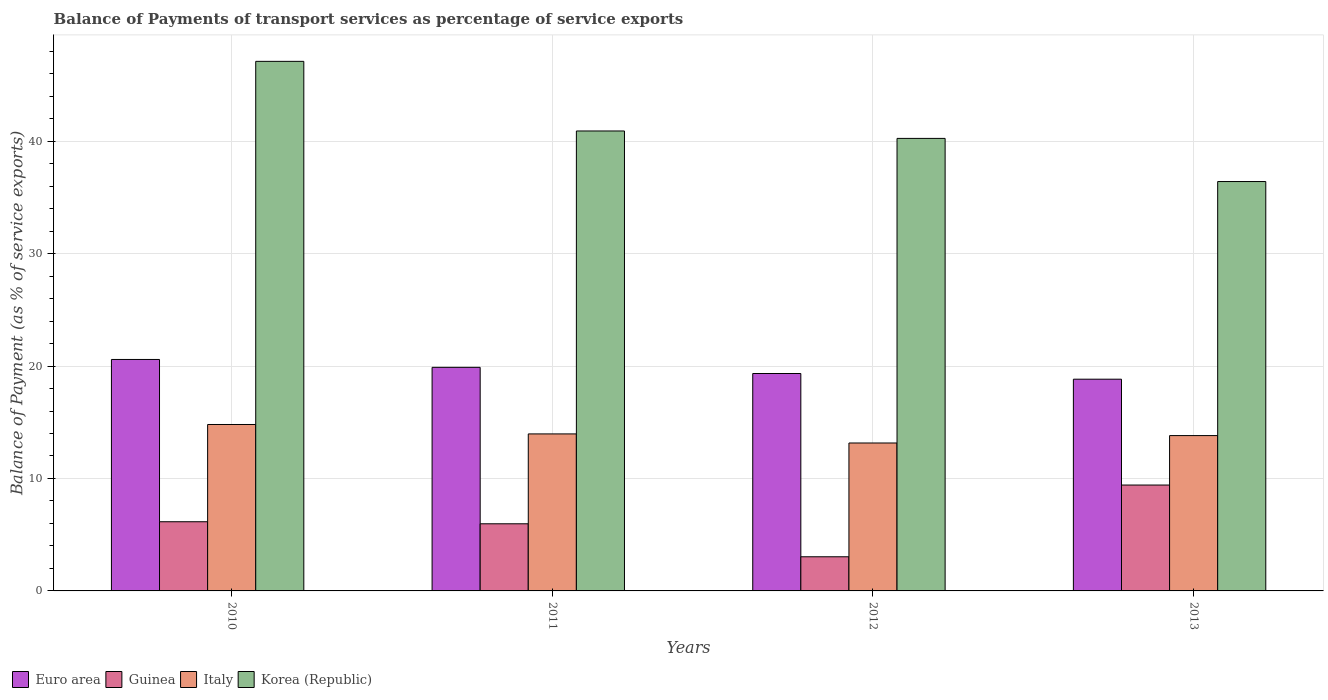How many groups of bars are there?
Give a very brief answer. 4. How many bars are there on the 1st tick from the left?
Your response must be concise. 4. What is the label of the 1st group of bars from the left?
Your response must be concise. 2010. What is the balance of payments of transport services in Guinea in 2010?
Ensure brevity in your answer.  6.15. Across all years, what is the maximum balance of payments of transport services in Guinea?
Provide a short and direct response. 9.42. Across all years, what is the minimum balance of payments of transport services in Italy?
Offer a very short reply. 13.16. In which year was the balance of payments of transport services in Guinea maximum?
Your answer should be very brief. 2013. What is the total balance of payments of transport services in Guinea in the graph?
Your answer should be very brief. 24.58. What is the difference between the balance of payments of transport services in Euro area in 2010 and that in 2012?
Provide a short and direct response. 1.25. What is the difference between the balance of payments of transport services in Italy in 2012 and the balance of payments of transport services in Euro area in 2013?
Your answer should be very brief. -5.67. What is the average balance of payments of transport services in Euro area per year?
Give a very brief answer. 19.66. In the year 2011, what is the difference between the balance of payments of transport services in Guinea and balance of payments of transport services in Italy?
Offer a terse response. -7.99. What is the ratio of the balance of payments of transport services in Euro area in 2011 to that in 2012?
Provide a short and direct response. 1.03. Is the balance of payments of transport services in Euro area in 2010 less than that in 2012?
Offer a terse response. No. Is the difference between the balance of payments of transport services in Guinea in 2012 and 2013 greater than the difference between the balance of payments of transport services in Italy in 2012 and 2013?
Offer a terse response. No. What is the difference between the highest and the second highest balance of payments of transport services in Euro area?
Provide a short and direct response. 0.7. What is the difference between the highest and the lowest balance of payments of transport services in Guinea?
Provide a succinct answer. 6.38. In how many years, is the balance of payments of transport services in Guinea greater than the average balance of payments of transport services in Guinea taken over all years?
Your response must be concise. 2. Is it the case that in every year, the sum of the balance of payments of transport services in Korea (Republic) and balance of payments of transport services in Guinea is greater than the sum of balance of payments of transport services in Euro area and balance of payments of transport services in Italy?
Provide a short and direct response. Yes. Are all the bars in the graph horizontal?
Your response must be concise. No. What is the difference between two consecutive major ticks on the Y-axis?
Your answer should be compact. 10. Are the values on the major ticks of Y-axis written in scientific E-notation?
Your response must be concise. No. Where does the legend appear in the graph?
Ensure brevity in your answer.  Bottom left. How many legend labels are there?
Ensure brevity in your answer.  4. What is the title of the graph?
Your response must be concise. Balance of Payments of transport services as percentage of service exports. Does "Cambodia" appear as one of the legend labels in the graph?
Give a very brief answer. No. What is the label or title of the X-axis?
Provide a succinct answer. Years. What is the label or title of the Y-axis?
Your answer should be very brief. Balance of Payment (as % of service exports). What is the Balance of Payment (as % of service exports) in Euro area in 2010?
Your answer should be very brief. 20.59. What is the Balance of Payment (as % of service exports) in Guinea in 2010?
Your answer should be very brief. 6.15. What is the Balance of Payment (as % of service exports) of Italy in 2010?
Make the answer very short. 14.8. What is the Balance of Payment (as % of service exports) of Korea (Republic) in 2010?
Provide a succinct answer. 47.1. What is the Balance of Payment (as % of service exports) of Euro area in 2011?
Your answer should be very brief. 19.89. What is the Balance of Payment (as % of service exports) of Guinea in 2011?
Your answer should be very brief. 5.97. What is the Balance of Payment (as % of service exports) in Italy in 2011?
Your answer should be compact. 13.96. What is the Balance of Payment (as % of service exports) of Korea (Republic) in 2011?
Your answer should be very brief. 40.91. What is the Balance of Payment (as % of service exports) in Euro area in 2012?
Your response must be concise. 19.34. What is the Balance of Payment (as % of service exports) of Guinea in 2012?
Your answer should be compact. 3.04. What is the Balance of Payment (as % of service exports) in Italy in 2012?
Ensure brevity in your answer.  13.16. What is the Balance of Payment (as % of service exports) of Korea (Republic) in 2012?
Offer a very short reply. 40.25. What is the Balance of Payment (as % of service exports) of Euro area in 2013?
Provide a short and direct response. 18.83. What is the Balance of Payment (as % of service exports) in Guinea in 2013?
Offer a terse response. 9.42. What is the Balance of Payment (as % of service exports) in Italy in 2013?
Keep it short and to the point. 13.82. What is the Balance of Payment (as % of service exports) in Korea (Republic) in 2013?
Provide a succinct answer. 36.41. Across all years, what is the maximum Balance of Payment (as % of service exports) of Euro area?
Give a very brief answer. 20.59. Across all years, what is the maximum Balance of Payment (as % of service exports) of Guinea?
Your response must be concise. 9.42. Across all years, what is the maximum Balance of Payment (as % of service exports) in Italy?
Your answer should be compact. 14.8. Across all years, what is the maximum Balance of Payment (as % of service exports) of Korea (Republic)?
Your answer should be very brief. 47.1. Across all years, what is the minimum Balance of Payment (as % of service exports) in Euro area?
Your answer should be very brief. 18.83. Across all years, what is the minimum Balance of Payment (as % of service exports) in Guinea?
Your answer should be compact. 3.04. Across all years, what is the minimum Balance of Payment (as % of service exports) in Italy?
Make the answer very short. 13.16. Across all years, what is the minimum Balance of Payment (as % of service exports) of Korea (Republic)?
Provide a short and direct response. 36.41. What is the total Balance of Payment (as % of service exports) in Euro area in the graph?
Give a very brief answer. 78.64. What is the total Balance of Payment (as % of service exports) of Guinea in the graph?
Provide a succinct answer. 24.58. What is the total Balance of Payment (as % of service exports) in Italy in the graph?
Give a very brief answer. 55.74. What is the total Balance of Payment (as % of service exports) of Korea (Republic) in the graph?
Offer a terse response. 164.67. What is the difference between the Balance of Payment (as % of service exports) of Euro area in 2010 and that in 2011?
Ensure brevity in your answer.  0.7. What is the difference between the Balance of Payment (as % of service exports) in Guinea in 2010 and that in 2011?
Make the answer very short. 0.18. What is the difference between the Balance of Payment (as % of service exports) of Italy in 2010 and that in 2011?
Offer a terse response. 0.84. What is the difference between the Balance of Payment (as % of service exports) in Korea (Republic) in 2010 and that in 2011?
Keep it short and to the point. 6.19. What is the difference between the Balance of Payment (as % of service exports) in Euro area in 2010 and that in 2012?
Your answer should be compact. 1.25. What is the difference between the Balance of Payment (as % of service exports) in Guinea in 2010 and that in 2012?
Your answer should be compact. 3.12. What is the difference between the Balance of Payment (as % of service exports) in Italy in 2010 and that in 2012?
Offer a very short reply. 1.65. What is the difference between the Balance of Payment (as % of service exports) of Korea (Republic) in 2010 and that in 2012?
Give a very brief answer. 6.85. What is the difference between the Balance of Payment (as % of service exports) in Euro area in 2010 and that in 2013?
Offer a terse response. 1.75. What is the difference between the Balance of Payment (as % of service exports) of Guinea in 2010 and that in 2013?
Your response must be concise. -3.26. What is the difference between the Balance of Payment (as % of service exports) in Italy in 2010 and that in 2013?
Give a very brief answer. 0.99. What is the difference between the Balance of Payment (as % of service exports) in Korea (Republic) in 2010 and that in 2013?
Keep it short and to the point. 10.69. What is the difference between the Balance of Payment (as % of service exports) of Euro area in 2011 and that in 2012?
Give a very brief answer. 0.55. What is the difference between the Balance of Payment (as % of service exports) of Guinea in 2011 and that in 2012?
Provide a short and direct response. 2.93. What is the difference between the Balance of Payment (as % of service exports) in Italy in 2011 and that in 2012?
Ensure brevity in your answer.  0.81. What is the difference between the Balance of Payment (as % of service exports) of Korea (Republic) in 2011 and that in 2012?
Ensure brevity in your answer.  0.66. What is the difference between the Balance of Payment (as % of service exports) in Euro area in 2011 and that in 2013?
Make the answer very short. 1.06. What is the difference between the Balance of Payment (as % of service exports) in Guinea in 2011 and that in 2013?
Ensure brevity in your answer.  -3.45. What is the difference between the Balance of Payment (as % of service exports) of Italy in 2011 and that in 2013?
Ensure brevity in your answer.  0.15. What is the difference between the Balance of Payment (as % of service exports) of Korea (Republic) in 2011 and that in 2013?
Your answer should be compact. 4.5. What is the difference between the Balance of Payment (as % of service exports) of Euro area in 2012 and that in 2013?
Ensure brevity in your answer.  0.51. What is the difference between the Balance of Payment (as % of service exports) of Guinea in 2012 and that in 2013?
Your response must be concise. -6.38. What is the difference between the Balance of Payment (as % of service exports) of Italy in 2012 and that in 2013?
Give a very brief answer. -0.66. What is the difference between the Balance of Payment (as % of service exports) in Korea (Republic) in 2012 and that in 2013?
Provide a succinct answer. 3.84. What is the difference between the Balance of Payment (as % of service exports) in Euro area in 2010 and the Balance of Payment (as % of service exports) in Guinea in 2011?
Your answer should be compact. 14.62. What is the difference between the Balance of Payment (as % of service exports) in Euro area in 2010 and the Balance of Payment (as % of service exports) in Italy in 2011?
Ensure brevity in your answer.  6.62. What is the difference between the Balance of Payment (as % of service exports) of Euro area in 2010 and the Balance of Payment (as % of service exports) of Korea (Republic) in 2011?
Ensure brevity in your answer.  -20.32. What is the difference between the Balance of Payment (as % of service exports) of Guinea in 2010 and the Balance of Payment (as % of service exports) of Italy in 2011?
Keep it short and to the point. -7.81. What is the difference between the Balance of Payment (as % of service exports) of Guinea in 2010 and the Balance of Payment (as % of service exports) of Korea (Republic) in 2011?
Offer a very short reply. -34.75. What is the difference between the Balance of Payment (as % of service exports) of Italy in 2010 and the Balance of Payment (as % of service exports) of Korea (Republic) in 2011?
Provide a short and direct response. -26.1. What is the difference between the Balance of Payment (as % of service exports) of Euro area in 2010 and the Balance of Payment (as % of service exports) of Guinea in 2012?
Provide a short and direct response. 17.55. What is the difference between the Balance of Payment (as % of service exports) in Euro area in 2010 and the Balance of Payment (as % of service exports) in Italy in 2012?
Ensure brevity in your answer.  7.43. What is the difference between the Balance of Payment (as % of service exports) of Euro area in 2010 and the Balance of Payment (as % of service exports) of Korea (Republic) in 2012?
Ensure brevity in your answer.  -19.66. What is the difference between the Balance of Payment (as % of service exports) of Guinea in 2010 and the Balance of Payment (as % of service exports) of Italy in 2012?
Give a very brief answer. -7. What is the difference between the Balance of Payment (as % of service exports) in Guinea in 2010 and the Balance of Payment (as % of service exports) in Korea (Republic) in 2012?
Provide a succinct answer. -34.1. What is the difference between the Balance of Payment (as % of service exports) of Italy in 2010 and the Balance of Payment (as % of service exports) of Korea (Republic) in 2012?
Provide a succinct answer. -25.45. What is the difference between the Balance of Payment (as % of service exports) in Euro area in 2010 and the Balance of Payment (as % of service exports) in Guinea in 2013?
Your response must be concise. 11.17. What is the difference between the Balance of Payment (as % of service exports) in Euro area in 2010 and the Balance of Payment (as % of service exports) in Italy in 2013?
Your answer should be compact. 6.77. What is the difference between the Balance of Payment (as % of service exports) of Euro area in 2010 and the Balance of Payment (as % of service exports) of Korea (Republic) in 2013?
Give a very brief answer. -15.83. What is the difference between the Balance of Payment (as % of service exports) in Guinea in 2010 and the Balance of Payment (as % of service exports) in Italy in 2013?
Offer a terse response. -7.66. What is the difference between the Balance of Payment (as % of service exports) of Guinea in 2010 and the Balance of Payment (as % of service exports) of Korea (Republic) in 2013?
Keep it short and to the point. -30.26. What is the difference between the Balance of Payment (as % of service exports) of Italy in 2010 and the Balance of Payment (as % of service exports) of Korea (Republic) in 2013?
Make the answer very short. -21.61. What is the difference between the Balance of Payment (as % of service exports) in Euro area in 2011 and the Balance of Payment (as % of service exports) in Guinea in 2012?
Your answer should be compact. 16.85. What is the difference between the Balance of Payment (as % of service exports) of Euro area in 2011 and the Balance of Payment (as % of service exports) of Italy in 2012?
Offer a terse response. 6.73. What is the difference between the Balance of Payment (as % of service exports) in Euro area in 2011 and the Balance of Payment (as % of service exports) in Korea (Republic) in 2012?
Keep it short and to the point. -20.36. What is the difference between the Balance of Payment (as % of service exports) in Guinea in 2011 and the Balance of Payment (as % of service exports) in Italy in 2012?
Keep it short and to the point. -7.19. What is the difference between the Balance of Payment (as % of service exports) of Guinea in 2011 and the Balance of Payment (as % of service exports) of Korea (Republic) in 2012?
Provide a short and direct response. -34.28. What is the difference between the Balance of Payment (as % of service exports) of Italy in 2011 and the Balance of Payment (as % of service exports) of Korea (Republic) in 2012?
Your response must be concise. -26.28. What is the difference between the Balance of Payment (as % of service exports) in Euro area in 2011 and the Balance of Payment (as % of service exports) in Guinea in 2013?
Offer a terse response. 10.47. What is the difference between the Balance of Payment (as % of service exports) of Euro area in 2011 and the Balance of Payment (as % of service exports) of Italy in 2013?
Provide a short and direct response. 6.07. What is the difference between the Balance of Payment (as % of service exports) of Euro area in 2011 and the Balance of Payment (as % of service exports) of Korea (Republic) in 2013?
Your answer should be compact. -16.52. What is the difference between the Balance of Payment (as % of service exports) of Guinea in 2011 and the Balance of Payment (as % of service exports) of Italy in 2013?
Provide a succinct answer. -7.85. What is the difference between the Balance of Payment (as % of service exports) in Guinea in 2011 and the Balance of Payment (as % of service exports) in Korea (Republic) in 2013?
Offer a very short reply. -30.44. What is the difference between the Balance of Payment (as % of service exports) in Italy in 2011 and the Balance of Payment (as % of service exports) in Korea (Republic) in 2013?
Offer a very short reply. -22.45. What is the difference between the Balance of Payment (as % of service exports) of Euro area in 2012 and the Balance of Payment (as % of service exports) of Guinea in 2013?
Offer a very short reply. 9.92. What is the difference between the Balance of Payment (as % of service exports) in Euro area in 2012 and the Balance of Payment (as % of service exports) in Italy in 2013?
Ensure brevity in your answer.  5.52. What is the difference between the Balance of Payment (as % of service exports) of Euro area in 2012 and the Balance of Payment (as % of service exports) of Korea (Republic) in 2013?
Your answer should be compact. -17.07. What is the difference between the Balance of Payment (as % of service exports) of Guinea in 2012 and the Balance of Payment (as % of service exports) of Italy in 2013?
Keep it short and to the point. -10.78. What is the difference between the Balance of Payment (as % of service exports) of Guinea in 2012 and the Balance of Payment (as % of service exports) of Korea (Republic) in 2013?
Your response must be concise. -33.37. What is the difference between the Balance of Payment (as % of service exports) of Italy in 2012 and the Balance of Payment (as % of service exports) of Korea (Republic) in 2013?
Make the answer very short. -23.25. What is the average Balance of Payment (as % of service exports) in Euro area per year?
Provide a succinct answer. 19.66. What is the average Balance of Payment (as % of service exports) in Guinea per year?
Give a very brief answer. 6.14. What is the average Balance of Payment (as % of service exports) of Italy per year?
Keep it short and to the point. 13.94. What is the average Balance of Payment (as % of service exports) in Korea (Republic) per year?
Make the answer very short. 41.17. In the year 2010, what is the difference between the Balance of Payment (as % of service exports) in Euro area and Balance of Payment (as % of service exports) in Guinea?
Your response must be concise. 14.43. In the year 2010, what is the difference between the Balance of Payment (as % of service exports) in Euro area and Balance of Payment (as % of service exports) in Italy?
Ensure brevity in your answer.  5.78. In the year 2010, what is the difference between the Balance of Payment (as % of service exports) of Euro area and Balance of Payment (as % of service exports) of Korea (Republic)?
Provide a short and direct response. -26.51. In the year 2010, what is the difference between the Balance of Payment (as % of service exports) in Guinea and Balance of Payment (as % of service exports) in Italy?
Offer a very short reply. -8.65. In the year 2010, what is the difference between the Balance of Payment (as % of service exports) in Guinea and Balance of Payment (as % of service exports) in Korea (Republic)?
Make the answer very short. -40.95. In the year 2010, what is the difference between the Balance of Payment (as % of service exports) of Italy and Balance of Payment (as % of service exports) of Korea (Republic)?
Ensure brevity in your answer.  -32.3. In the year 2011, what is the difference between the Balance of Payment (as % of service exports) of Euro area and Balance of Payment (as % of service exports) of Guinea?
Your answer should be compact. 13.92. In the year 2011, what is the difference between the Balance of Payment (as % of service exports) in Euro area and Balance of Payment (as % of service exports) in Italy?
Your answer should be very brief. 5.92. In the year 2011, what is the difference between the Balance of Payment (as % of service exports) in Euro area and Balance of Payment (as % of service exports) in Korea (Republic)?
Offer a terse response. -21.02. In the year 2011, what is the difference between the Balance of Payment (as % of service exports) of Guinea and Balance of Payment (as % of service exports) of Italy?
Ensure brevity in your answer.  -7.99. In the year 2011, what is the difference between the Balance of Payment (as % of service exports) of Guinea and Balance of Payment (as % of service exports) of Korea (Republic)?
Your response must be concise. -34.94. In the year 2011, what is the difference between the Balance of Payment (as % of service exports) of Italy and Balance of Payment (as % of service exports) of Korea (Republic)?
Your answer should be compact. -26.94. In the year 2012, what is the difference between the Balance of Payment (as % of service exports) in Euro area and Balance of Payment (as % of service exports) in Guinea?
Make the answer very short. 16.3. In the year 2012, what is the difference between the Balance of Payment (as % of service exports) of Euro area and Balance of Payment (as % of service exports) of Italy?
Give a very brief answer. 6.18. In the year 2012, what is the difference between the Balance of Payment (as % of service exports) in Euro area and Balance of Payment (as % of service exports) in Korea (Republic)?
Provide a succinct answer. -20.91. In the year 2012, what is the difference between the Balance of Payment (as % of service exports) of Guinea and Balance of Payment (as % of service exports) of Italy?
Offer a very short reply. -10.12. In the year 2012, what is the difference between the Balance of Payment (as % of service exports) in Guinea and Balance of Payment (as % of service exports) in Korea (Republic)?
Give a very brief answer. -37.21. In the year 2012, what is the difference between the Balance of Payment (as % of service exports) in Italy and Balance of Payment (as % of service exports) in Korea (Republic)?
Your response must be concise. -27.09. In the year 2013, what is the difference between the Balance of Payment (as % of service exports) of Euro area and Balance of Payment (as % of service exports) of Guinea?
Keep it short and to the point. 9.41. In the year 2013, what is the difference between the Balance of Payment (as % of service exports) of Euro area and Balance of Payment (as % of service exports) of Italy?
Your response must be concise. 5.02. In the year 2013, what is the difference between the Balance of Payment (as % of service exports) in Euro area and Balance of Payment (as % of service exports) in Korea (Republic)?
Provide a short and direct response. -17.58. In the year 2013, what is the difference between the Balance of Payment (as % of service exports) of Guinea and Balance of Payment (as % of service exports) of Italy?
Make the answer very short. -4.4. In the year 2013, what is the difference between the Balance of Payment (as % of service exports) of Guinea and Balance of Payment (as % of service exports) of Korea (Republic)?
Offer a terse response. -26.99. In the year 2013, what is the difference between the Balance of Payment (as % of service exports) in Italy and Balance of Payment (as % of service exports) in Korea (Republic)?
Offer a very short reply. -22.6. What is the ratio of the Balance of Payment (as % of service exports) of Euro area in 2010 to that in 2011?
Provide a short and direct response. 1.04. What is the ratio of the Balance of Payment (as % of service exports) of Guinea in 2010 to that in 2011?
Provide a short and direct response. 1.03. What is the ratio of the Balance of Payment (as % of service exports) in Italy in 2010 to that in 2011?
Ensure brevity in your answer.  1.06. What is the ratio of the Balance of Payment (as % of service exports) in Korea (Republic) in 2010 to that in 2011?
Give a very brief answer. 1.15. What is the ratio of the Balance of Payment (as % of service exports) in Euro area in 2010 to that in 2012?
Offer a terse response. 1.06. What is the ratio of the Balance of Payment (as % of service exports) in Guinea in 2010 to that in 2012?
Provide a succinct answer. 2.03. What is the ratio of the Balance of Payment (as % of service exports) of Italy in 2010 to that in 2012?
Offer a terse response. 1.13. What is the ratio of the Balance of Payment (as % of service exports) in Korea (Republic) in 2010 to that in 2012?
Ensure brevity in your answer.  1.17. What is the ratio of the Balance of Payment (as % of service exports) in Euro area in 2010 to that in 2013?
Make the answer very short. 1.09. What is the ratio of the Balance of Payment (as % of service exports) in Guinea in 2010 to that in 2013?
Your answer should be very brief. 0.65. What is the ratio of the Balance of Payment (as % of service exports) in Italy in 2010 to that in 2013?
Provide a succinct answer. 1.07. What is the ratio of the Balance of Payment (as % of service exports) in Korea (Republic) in 2010 to that in 2013?
Your answer should be compact. 1.29. What is the ratio of the Balance of Payment (as % of service exports) of Euro area in 2011 to that in 2012?
Offer a very short reply. 1.03. What is the ratio of the Balance of Payment (as % of service exports) in Guinea in 2011 to that in 2012?
Keep it short and to the point. 1.97. What is the ratio of the Balance of Payment (as % of service exports) in Italy in 2011 to that in 2012?
Your answer should be compact. 1.06. What is the ratio of the Balance of Payment (as % of service exports) in Korea (Republic) in 2011 to that in 2012?
Your answer should be compact. 1.02. What is the ratio of the Balance of Payment (as % of service exports) of Euro area in 2011 to that in 2013?
Provide a succinct answer. 1.06. What is the ratio of the Balance of Payment (as % of service exports) of Guinea in 2011 to that in 2013?
Offer a very short reply. 0.63. What is the ratio of the Balance of Payment (as % of service exports) in Italy in 2011 to that in 2013?
Keep it short and to the point. 1.01. What is the ratio of the Balance of Payment (as % of service exports) in Korea (Republic) in 2011 to that in 2013?
Your answer should be compact. 1.12. What is the ratio of the Balance of Payment (as % of service exports) of Euro area in 2012 to that in 2013?
Give a very brief answer. 1.03. What is the ratio of the Balance of Payment (as % of service exports) in Guinea in 2012 to that in 2013?
Give a very brief answer. 0.32. What is the ratio of the Balance of Payment (as % of service exports) in Italy in 2012 to that in 2013?
Make the answer very short. 0.95. What is the ratio of the Balance of Payment (as % of service exports) in Korea (Republic) in 2012 to that in 2013?
Your answer should be very brief. 1.11. What is the difference between the highest and the second highest Balance of Payment (as % of service exports) in Euro area?
Give a very brief answer. 0.7. What is the difference between the highest and the second highest Balance of Payment (as % of service exports) of Guinea?
Give a very brief answer. 3.26. What is the difference between the highest and the second highest Balance of Payment (as % of service exports) in Italy?
Your answer should be very brief. 0.84. What is the difference between the highest and the second highest Balance of Payment (as % of service exports) of Korea (Republic)?
Your answer should be very brief. 6.19. What is the difference between the highest and the lowest Balance of Payment (as % of service exports) in Euro area?
Provide a succinct answer. 1.75. What is the difference between the highest and the lowest Balance of Payment (as % of service exports) of Guinea?
Your answer should be very brief. 6.38. What is the difference between the highest and the lowest Balance of Payment (as % of service exports) of Italy?
Make the answer very short. 1.65. What is the difference between the highest and the lowest Balance of Payment (as % of service exports) of Korea (Republic)?
Your response must be concise. 10.69. 